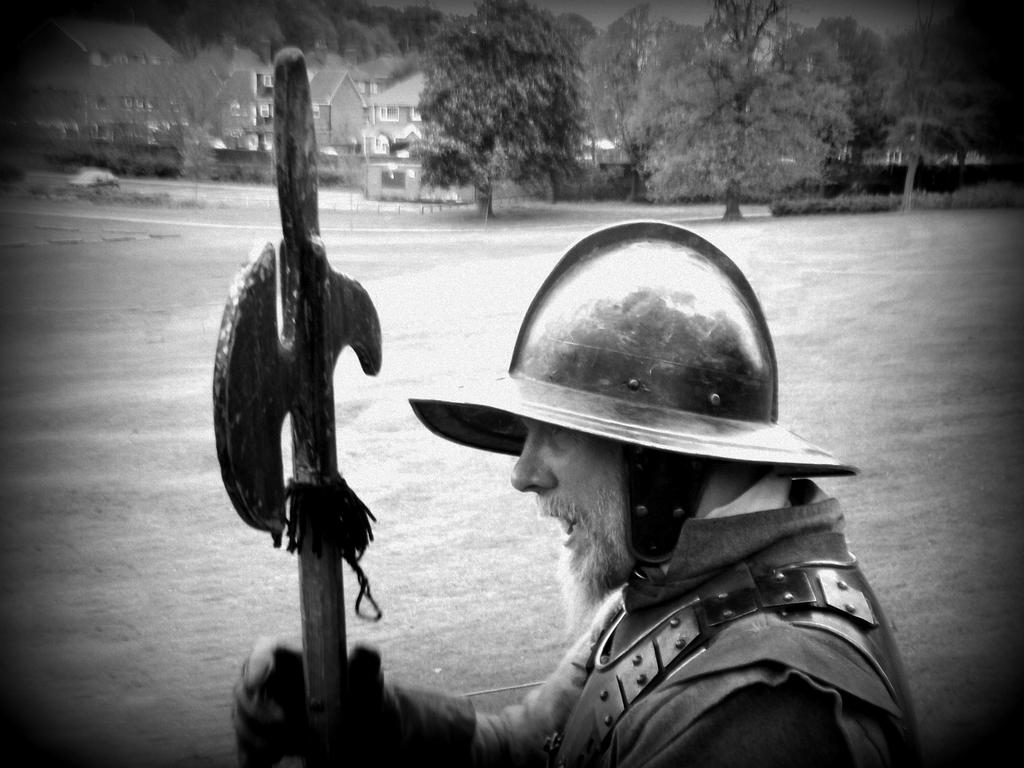What is the main subject of the image? There is a man standing in the middle of the image. What is the man holding in the image? The man is holding an axe. What type of terrain is visible behind the man? There is grass behind the man. What can be seen in the distance at the top of the image? Trees, buildings, and a vehicle are visible at the top of the image. What type of office furniture can be seen in the image? There is no office furniture present in the image. What branch of the military is the man representing in the image? The image does not provide any information about the man's affiliation with the military, and there is no indication of a military presence in the image. 